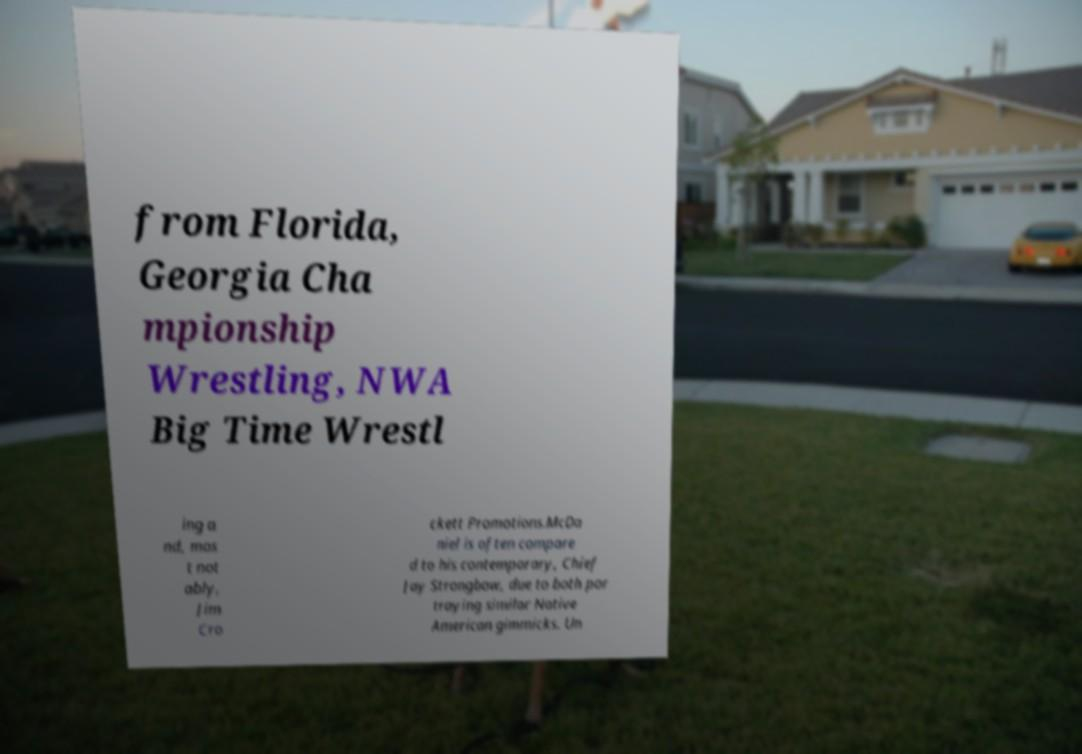For documentation purposes, I need the text within this image transcribed. Could you provide that? from Florida, Georgia Cha mpionship Wrestling, NWA Big Time Wrestl ing a nd, mos t not ably, Jim Cro ckett Promotions.McDa niel is often compare d to his contemporary, Chief Jay Strongbow, due to both por traying similar Native American gimmicks. Un 